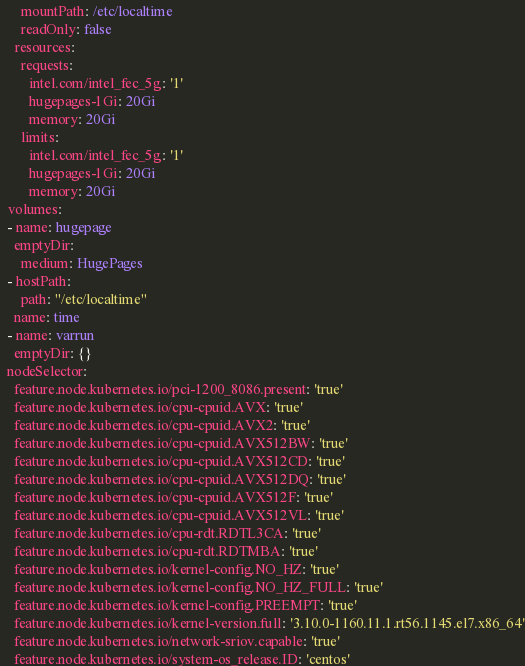<code> <loc_0><loc_0><loc_500><loc_500><_YAML_>      mountPath: /etc/localtime
      readOnly: false
    resources:
      requests:
        intel.com/intel_fec_5g: '1'
        hugepages-1Gi: 20Gi
        memory: 20Gi
      limits:
        intel.com/intel_fec_5g: '1'
        hugepages-1Gi: 20Gi
        memory: 20Gi
  volumes:
  - name: hugepage
    emptyDir:
      medium: HugePages
  - hostPath:
      path: "/etc/localtime"
    name: time
  - name: varrun
    emptyDir: {}
  nodeSelector:
    feature.node.kubernetes.io/pci-1200_8086.present: 'true'
    feature.node.kubernetes.io/cpu-cpuid.AVX: 'true'
    feature.node.kubernetes.io/cpu-cpuid.AVX2: 'true'
    feature.node.kubernetes.io/cpu-cpuid.AVX512BW: 'true'
    feature.node.kubernetes.io/cpu-cpuid.AVX512CD: 'true'
    feature.node.kubernetes.io/cpu-cpuid.AVX512DQ: 'true'
    feature.node.kubernetes.io/cpu-cpuid.AVX512F: 'true'
    feature.node.kubernetes.io/cpu-cpuid.AVX512VL: 'true'
    feature.node.kubernetes.io/cpu-rdt.RDTL3CA: 'true'
    feature.node.kubernetes.io/cpu-rdt.RDTMBA: 'true'
    feature.node.kubernetes.io/kernel-config.NO_HZ: 'true'
    feature.node.kubernetes.io/kernel-config.NO_HZ_FULL: 'true'
    feature.node.kubernetes.io/kernel-config.PREEMPT: 'true'
    feature.node.kubernetes.io/kernel-version.full: '3.10.0-1160.11.1.rt56.1145.el7.x86_64'
    feature.node.kubernetes.io/network-sriov.capable: 'true'
    feature.node.kubernetes.io/system-os_release.ID: 'centos'
</code> 